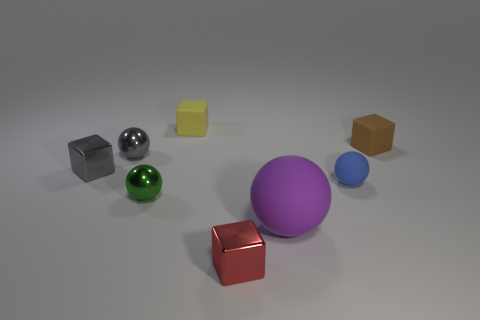Subtract 1 blocks. How many blocks are left? 3 Add 1 metallic balls. How many objects exist? 9 Add 8 small blue objects. How many small blue objects are left? 9 Add 8 small yellow cubes. How many small yellow cubes exist? 9 Subtract 0 brown cylinders. How many objects are left? 8 Subtract all large purple spheres. Subtract all green things. How many objects are left? 6 